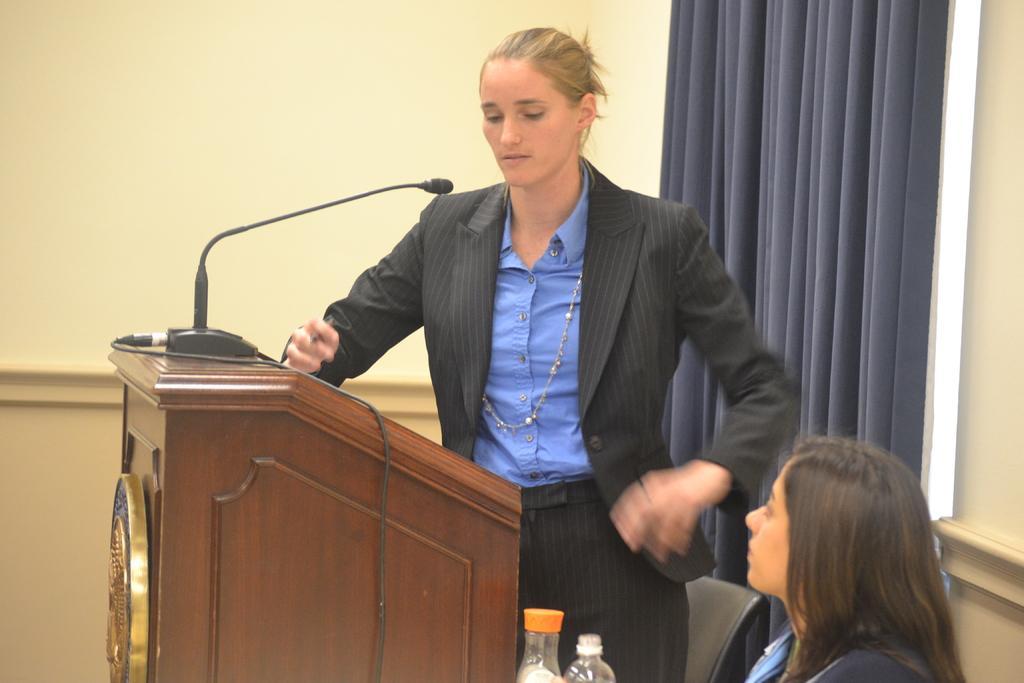Please provide a concise description of this image. In this image we can see a lady standing, before her there is a podium and we can see mics. At the bottom there is a person sitting and we can see bottles. In the background there is a wall and we can see a curtain. 